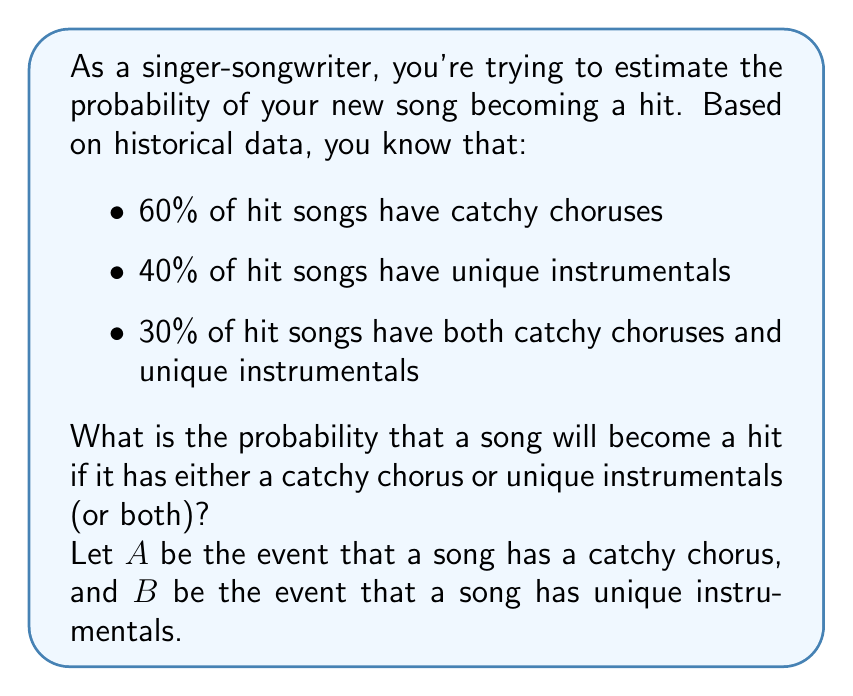Solve this math problem. To solve this problem, we'll use the addition rule of probability. We want to find P(A ∪ B), which is the probability of A or B (or both) occurring.

The addition rule states:
$$ P(A \cup B) = P(A) + P(B) - P(A \cap B) $$

Given:
$P(A) = 0.60$ (probability of a catchy chorus)
$P(B) = 0.40$ (probability of unique instrumentals)
$P(A \cap B) = 0.30$ (probability of both catchy chorus and unique instrumentals)

Let's substitute these values into the formula:

$$ P(A \cup B) = 0.60 + 0.40 - 0.30 $$

Now, let's calculate:

$$ P(A \cup B) = 1.00 - 0.30 = 0.70 $$

Therefore, the probability that a song will become a hit if it has either a catchy chorus or unique instrumentals (or both) is 0.70 or 70%.
Answer: 0.70 or 70% 